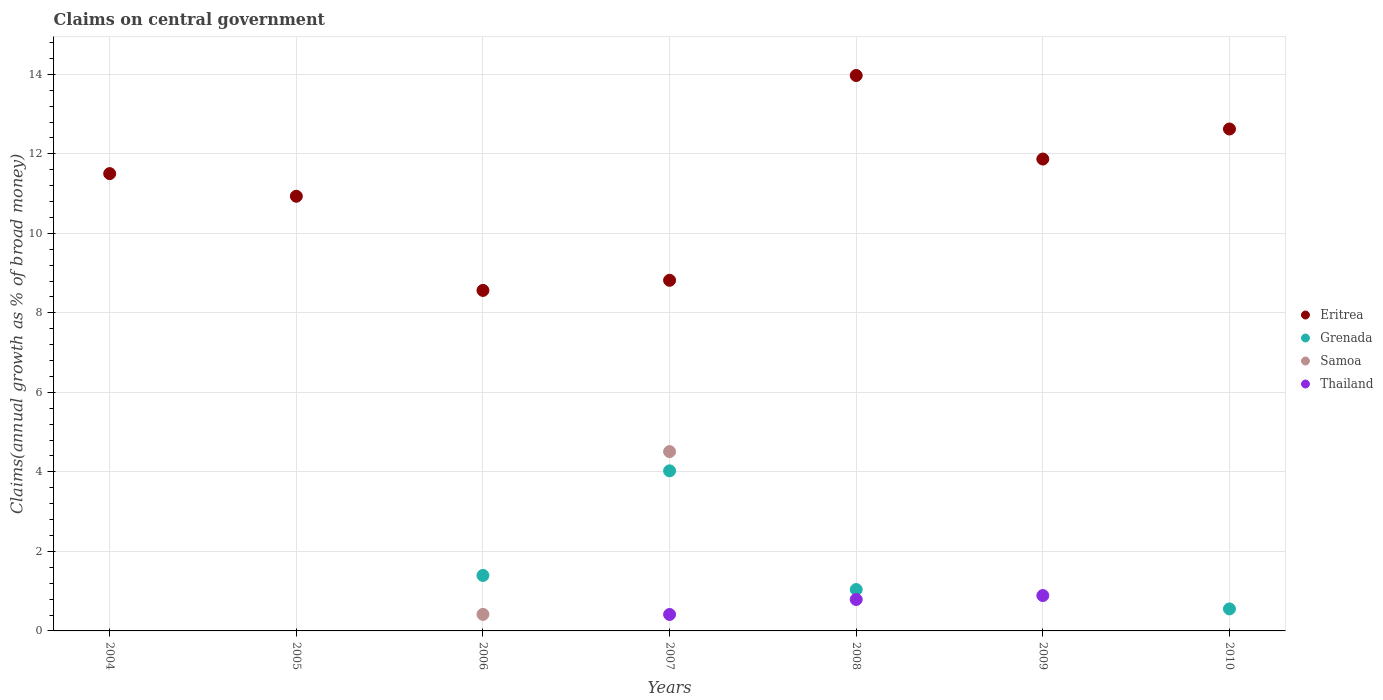How many different coloured dotlines are there?
Keep it short and to the point. 4. What is the percentage of broad money claimed on centeral government in Samoa in 2009?
Your answer should be compact. 0. Across all years, what is the maximum percentage of broad money claimed on centeral government in Thailand?
Offer a very short reply. 0.89. Across all years, what is the minimum percentage of broad money claimed on centeral government in Samoa?
Provide a succinct answer. 0. What is the total percentage of broad money claimed on centeral government in Eritrea in the graph?
Your answer should be very brief. 78.28. What is the difference between the percentage of broad money claimed on centeral government in Thailand in 2007 and that in 2009?
Offer a very short reply. -0.48. What is the difference between the percentage of broad money claimed on centeral government in Eritrea in 2006 and the percentage of broad money claimed on centeral government in Samoa in 2005?
Offer a very short reply. 8.56. What is the average percentage of broad money claimed on centeral government in Thailand per year?
Provide a succinct answer. 0.3. In the year 2007, what is the difference between the percentage of broad money claimed on centeral government in Grenada and percentage of broad money claimed on centeral government in Thailand?
Ensure brevity in your answer.  3.61. In how many years, is the percentage of broad money claimed on centeral government in Eritrea greater than 9.2 %?
Keep it short and to the point. 5. What is the ratio of the percentage of broad money claimed on centeral government in Grenada in 2008 to that in 2010?
Your response must be concise. 1.88. What is the difference between the highest and the second highest percentage of broad money claimed on centeral government in Grenada?
Keep it short and to the point. 2.63. What is the difference between the highest and the lowest percentage of broad money claimed on centeral government in Samoa?
Your response must be concise. 4.51. Is it the case that in every year, the sum of the percentage of broad money claimed on centeral government in Samoa and percentage of broad money claimed on centeral government in Eritrea  is greater than the sum of percentage of broad money claimed on centeral government in Thailand and percentage of broad money claimed on centeral government in Grenada?
Ensure brevity in your answer.  Yes. Is the percentage of broad money claimed on centeral government in Eritrea strictly greater than the percentage of broad money claimed on centeral government in Grenada over the years?
Your answer should be compact. Yes. Is the percentage of broad money claimed on centeral government in Eritrea strictly less than the percentage of broad money claimed on centeral government in Samoa over the years?
Keep it short and to the point. No. What is the difference between two consecutive major ticks on the Y-axis?
Keep it short and to the point. 2. Are the values on the major ticks of Y-axis written in scientific E-notation?
Provide a short and direct response. No. Does the graph contain any zero values?
Keep it short and to the point. Yes. Where does the legend appear in the graph?
Offer a very short reply. Center right. What is the title of the graph?
Give a very brief answer. Claims on central government. Does "Fiji" appear as one of the legend labels in the graph?
Ensure brevity in your answer.  No. What is the label or title of the X-axis?
Your answer should be compact. Years. What is the label or title of the Y-axis?
Keep it short and to the point. Claims(annual growth as % of broad money). What is the Claims(annual growth as % of broad money) in Eritrea in 2004?
Give a very brief answer. 11.5. What is the Claims(annual growth as % of broad money) in Thailand in 2004?
Offer a terse response. 0. What is the Claims(annual growth as % of broad money) in Eritrea in 2005?
Your answer should be very brief. 10.93. What is the Claims(annual growth as % of broad money) of Eritrea in 2006?
Your answer should be compact. 8.56. What is the Claims(annual growth as % of broad money) of Grenada in 2006?
Provide a short and direct response. 1.4. What is the Claims(annual growth as % of broad money) in Samoa in 2006?
Offer a very short reply. 0.42. What is the Claims(annual growth as % of broad money) in Thailand in 2006?
Ensure brevity in your answer.  0. What is the Claims(annual growth as % of broad money) in Eritrea in 2007?
Your response must be concise. 8.82. What is the Claims(annual growth as % of broad money) in Grenada in 2007?
Give a very brief answer. 4.03. What is the Claims(annual growth as % of broad money) in Samoa in 2007?
Ensure brevity in your answer.  4.51. What is the Claims(annual growth as % of broad money) in Thailand in 2007?
Give a very brief answer. 0.41. What is the Claims(annual growth as % of broad money) of Eritrea in 2008?
Your answer should be very brief. 13.97. What is the Claims(annual growth as % of broad money) in Grenada in 2008?
Your answer should be very brief. 1.04. What is the Claims(annual growth as % of broad money) in Samoa in 2008?
Provide a succinct answer. 0. What is the Claims(annual growth as % of broad money) of Thailand in 2008?
Provide a succinct answer. 0.79. What is the Claims(annual growth as % of broad money) in Eritrea in 2009?
Ensure brevity in your answer.  11.87. What is the Claims(annual growth as % of broad money) of Samoa in 2009?
Make the answer very short. 0. What is the Claims(annual growth as % of broad money) of Thailand in 2009?
Provide a succinct answer. 0.89. What is the Claims(annual growth as % of broad money) of Eritrea in 2010?
Your response must be concise. 12.62. What is the Claims(annual growth as % of broad money) in Grenada in 2010?
Ensure brevity in your answer.  0.55. What is the Claims(annual growth as % of broad money) in Samoa in 2010?
Ensure brevity in your answer.  0. Across all years, what is the maximum Claims(annual growth as % of broad money) of Eritrea?
Offer a very short reply. 13.97. Across all years, what is the maximum Claims(annual growth as % of broad money) of Grenada?
Your response must be concise. 4.03. Across all years, what is the maximum Claims(annual growth as % of broad money) of Samoa?
Make the answer very short. 4.51. Across all years, what is the maximum Claims(annual growth as % of broad money) in Thailand?
Ensure brevity in your answer.  0.89. Across all years, what is the minimum Claims(annual growth as % of broad money) in Eritrea?
Your answer should be very brief. 8.56. Across all years, what is the minimum Claims(annual growth as % of broad money) in Grenada?
Offer a very short reply. 0. Across all years, what is the minimum Claims(annual growth as % of broad money) in Samoa?
Provide a short and direct response. 0. What is the total Claims(annual growth as % of broad money) in Eritrea in the graph?
Provide a succinct answer. 78.28. What is the total Claims(annual growth as % of broad money) in Grenada in the graph?
Give a very brief answer. 7.02. What is the total Claims(annual growth as % of broad money) in Samoa in the graph?
Your response must be concise. 4.93. What is the total Claims(annual growth as % of broad money) of Thailand in the graph?
Your answer should be very brief. 2.09. What is the difference between the Claims(annual growth as % of broad money) in Eritrea in 2004 and that in 2005?
Provide a short and direct response. 0.57. What is the difference between the Claims(annual growth as % of broad money) of Eritrea in 2004 and that in 2006?
Provide a short and direct response. 2.94. What is the difference between the Claims(annual growth as % of broad money) in Eritrea in 2004 and that in 2007?
Make the answer very short. 2.68. What is the difference between the Claims(annual growth as % of broad money) in Eritrea in 2004 and that in 2008?
Provide a succinct answer. -2.47. What is the difference between the Claims(annual growth as % of broad money) in Eritrea in 2004 and that in 2009?
Provide a short and direct response. -0.37. What is the difference between the Claims(annual growth as % of broad money) of Eritrea in 2004 and that in 2010?
Your answer should be compact. -1.12. What is the difference between the Claims(annual growth as % of broad money) of Eritrea in 2005 and that in 2006?
Offer a terse response. 2.37. What is the difference between the Claims(annual growth as % of broad money) of Eritrea in 2005 and that in 2007?
Ensure brevity in your answer.  2.11. What is the difference between the Claims(annual growth as % of broad money) in Eritrea in 2005 and that in 2008?
Offer a very short reply. -3.04. What is the difference between the Claims(annual growth as % of broad money) in Eritrea in 2005 and that in 2009?
Ensure brevity in your answer.  -0.94. What is the difference between the Claims(annual growth as % of broad money) in Eritrea in 2005 and that in 2010?
Provide a short and direct response. -1.69. What is the difference between the Claims(annual growth as % of broad money) of Eritrea in 2006 and that in 2007?
Provide a succinct answer. -0.25. What is the difference between the Claims(annual growth as % of broad money) of Grenada in 2006 and that in 2007?
Keep it short and to the point. -2.63. What is the difference between the Claims(annual growth as % of broad money) of Samoa in 2006 and that in 2007?
Ensure brevity in your answer.  -4.09. What is the difference between the Claims(annual growth as % of broad money) in Eritrea in 2006 and that in 2008?
Make the answer very short. -5.41. What is the difference between the Claims(annual growth as % of broad money) of Grenada in 2006 and that in 2008?
Keep it short and to the point. 0.35. What is the difference between the Claims(annual growth as % of broad money) in Eritrea in 2006 and that in 2009?
Keep it short and to the point. -3.3. What is the difference between the Claims(annual growth as % of broad money) in Eritrea in 2006 and that in 2010?
Give a very brief answer. -4.06. What is the difference between the Claims(annual growth as % of broad money) in Grenada in 2006 and that in 2010?
Provide a short and direct response. 0.84. What is the difference between the Claims(annual growth as % of broad money) of Eritrea in 2007 and that in 2008?
Ensure brevity in your answer.  -5.15. What is the difference between the Claims(annual growth as % of broad money) of Grenada in 2007 and that in 2008?
Your answer should be compact. 2.98. What is the difference between the Claims(annual growth as % of broad money) of Thailand in 2007 and that in 2008?
Ensure brevity in your answer.  -0.38. What is the difference between the Claims(annual growth as % of broad money) in Eritrea in 2007 and that in 2009?
Your answer should be compact. -3.05. What is the difference between the Claims(annual growth as % of broad money) of Thailand in 2007 and that in 2009?
Offer a terse response. -0.48. What is the difference between the Claims(annual growth as % of broad money) in Eritrea in 2007 and that in 2010?
Give a very brief answer. -3.81. What is the difference between the Claims(annual growth as % of broad money) in Grenada in 2007 and that in 2010?
Make the answer very short. 3.47. What is the difference between the Claims(annual growth as % of broad money) of Eritrea in 2008 and that in 2009?
Offer a terse response. 2.1. What is the difference between the Claims(annual growth as % of broad money) in Thailand in 2008 and that in 2009?
Provide a succinct answer. -0.1. What is the difference between the Claims(annual growth as % of broad money) of Eritrea in 2008 and that in 2010?
Provide a succinct answer. 1.35. What is the difference between the Claims(annual growth as % of broad money) in Grenada in 2008 and that in 2010?
Give a very brief answer. 0.49. What is the difference between the Claims(annual growth as % of broad money) of Eritrea in 2009 and that in 2010?
Offer a very short reply. -0.76. What is the difference between the Claims(annual growth as % of broad money) of Eritrea in 2004 and the Claims(annual growth as % of broad money) of Grenada in 2006?
Offer a very short reply. 10.11. What is the difference between the Claims(annual growth as % of broad money) in Eritrea in 2004 and the Claims(annual growth as % of broad money) in Samoa in 2006?
Provide a succinct answer. 11.09. What is the difference between the Claims(annual growth as % of broad money) of Eritrea in 2004 and the Claims(annual growth as % of broad money) of Grenada in 2007?
Keep it short and to the point. 7.48. What is the difference between the Claims(annual growth as % of broad money) of Eritrea in 2004 and the Claims(annual growth as % of broad money) of Samoa in 2007?
Keep it short and to the point. 6.99. What is the difference between the Claims(annual growth as % of broad money) of Eritrea in 2004 and the Claims(annual growth as % of broad money) of Thailand in 2007?
Your response must be concise. 11.09. What is the difference between the Claims(annual growth as % of broad money) in Eritrea in 2004 and the Claims(annual growth as % of broad money) in Grenada in 2008?
Give a very brief answer. 10.46. What is the difference between the Claims(annual growth as % of broad money) of Eritrea in 2004 and the Claims(annual growth as % of broad money) of Thailand in 2008?
Offer a terse response. 10.71. What is the difference between the Claims(annual growth as % of broad money) in Eritrea in 2004 and the Claims(annual growth as % of broad money) in Thailand in 2009?
Make the answer very short. 10.61. What is the difference between the Claims(annual growth as % of broad money) in Eritrea in 2004 and the Claims(annual growth as % of broad money) in Grenada in 2010?
Ensure brevity in your answer.  10.95. What is the difference between the Claims(annual growth as % of broad money) of Eritrea in 2005 and the Claims(annual growth as % of broad money) of Grenada in 2006?
Your answer should be very brief. 9.54. What is the difference between the Claims(annual growth as % of broad money) of Eritrea in 2005 and the Claims(annual growth as % of broad money) of Samoa in 2006?
Offer a very short reply. 10.52. What is the difference between the Claims(annual growth as % of broad money) in Eritrea in 2005 and the Claims(annual growth as % of broad money) in Grenada in 2007?
Keep it short and to the point. 6.91. What is the difference between the Claims(annual growth as % of broad money) of Eritrea in 2005 and the Claims(annual growth as % of broad money) of Samoa in 2007?
Provide a succinct answer. 6.42. What is the difference between the Claims(annual growth as % of broad money) in Eritrea in 2005 and the Claims(annual growth as % of broad money) in Thailand in 2007?
Ensure brevity in your answer.  10.52. What is the difference between the Claims(annual growth as % of broad money) of Eritrea in 2005 and the Claims(annual growth as % of broad money) of Grenada in 2008?
Your answer should be compact. 9.89. What is the difference between the Claims(annual growth as % of broad money) of Eritrea in 2005 and the Claims(annual growth as % of broad money) of Thailand in 2008?
Your answer should be compact. 10.14. What is the difference between the Claims(annual growth as % of broad money) in Eritrea in 2005 and the Claims(annual growth as % of broad money) in Thailand in 2009?
Give a very brief answer. 10.04. What is the difference between the Claims(annual growth as % of broad money) of Eritrea in 2005 and the Claims(annual growth as % of broad money) of Grenada in 2010?
Your answer should be very brief. 10.38. What is the difference between the Claims(annual growth as % of broad money) of Eritrea in 2006 and the Claims(annual growth as % of broad money) of Grenada in 2007?
Keep it short and to the point. 4.54. What is the difference between the Claims(annual growth as % of broad money) in Eritrea in 2006 and the Claims(annual growth as % of broad money) in Samoa in 2007?
Ensure brevity in your answer.  4.05. What is the difference between the Claims(annual growth as % of broad money) in Eritrea in 2006 and the Claims(annual growth as % of broad money) in Thailand in 2007?
Ensure brevity in your answer.  8.15. What is the difference between the Claims(annual growth as % of broad money) in Grenada in 2006 and the Claims(annual growth as % of broad money) in Samoa in 2007?
Your answer should be very brief. -3.12. What is the difference between the Claims(annual growth as % of broad money) in Grenada in 2006 and the Claims(annual growth as % of broad money) in Thailand in 2007?
Offer a very short reply. 0.98. What is the difference between the Claims(annual growth as % of broad money) of Samoa in 2006 and the Claims(annual growth as % of broad money) of Thailand in 2007?
Your answer should be compact. 0. What is the difference between the Claims(annual growth as % of broad money) in Eritrea in 2006 and the Claims(annual growth as % of broad money) in Grenada in 2008?
Ensure brevity in your answer.  7.52. What is the difference between the Claims(annual growth as % of broad money) of Eritrea in 2006 and the Claims(annual growth as % of broad money) of Thailand in 2008?
Your response must be concise. 7.77. What is the difference between the Claims(annual growth as % of broad money) in Grenada in 2006 and the Claims(annual growth as % of broad money) in Thailand in 2008?
Give a very brief answer. 0.6. What is the difference between the Claims(annual growth as % of broad money) of Samoa in 2006 and the Claims(annual growth as % of broad money) of Thailand in 2008?
Offer a very short reply. -0.37. What is the difference between the Claims(annual growth as % of broad money) of Eritrea in 2006 and the Claims(annual growth as % of broad money) of Thailand in 2009?
Your answer should be compact. 7.68. What is the difference between the Claims(annual growth as % of broad money) of Grenada in 2006 and the Claims(annual growth as % of broad money) of Thailand in 2009?
Your answer should be compact. 0.51. What is the difference between the Claims(annual growth as % of broad money) in Samoa in 2006 and the Claims(annual growth as % of broad money) in Thailand in 2009?
Your answer should be very brief. -0.47. What is the difference between the Claims(annual growth as % of broad money) of Eritrea in 2006 and the Claims(annual growth as % of broad money) of Grenada in 2010?
Your answer should be compact. 8.01. What is the difference between the Claims(annual growth as % of broad money) of Eritrea in 2007 and the Claims(annual growth as % of broad money) of Grenada in 2008?
Ensure brevity in your answer.  7.78. What is the difference between the Claims(annual growth as % of broad money) of Eritrea in 2007 and the Claims(annual growth as % of broad money) of Thailand in 2008?
Ensure brevity in your answer.  8.03. What is the difference between the Claims(annual growth as % of broad money) in Grenada in 2007 and the Claims(annual growth as % of broad money) in Thailand in 2008?
Give a very brief answer. 3.24. What is the difference between the Claims(annual growth as % of broad money) in Samoa in 2007 and the Claims(annual growth as % of broad money) in Thailand in 2008?
Offer a terse response. 3.72. What is the difference between the Claims(annual growth as % of broad money) of Eritrea in 2007 and the Claims(annual growth as % of broad money) of Thailand in 2009?
Give a very brief answer. 7.93. What is the difference between the Claims(annual growth as % of broad money) in Grenada in 2007 and the Claims(annual growth as % of broad money) in Thailand in 2009?
Keep it short and to the point. 3.14. What is the difference between the Claims(annual growth as % of broad money) in Samoa in 2007 and the Claims(annual growth as % of broad money) in Thailand in 2009?
Ensure brevity in your answer.  3.62. What is the difference between the Claims(annual growth as % of broad money) in Eritrea in 2007 and the Claims(annual growth as % of broad money) in Grenada in 2010?
Give a very brief answer. 8.26. What is the difference between the Claims(annual growth as % of broad money) of Eritrea in 2008 and the Claims(annual growth as % of broad money) of Thailand in 2009?
Offer a terse response. 13.08. What is the difference between the Claims(annual growth as % of broad money) in Grenada in 2008 and the Claims(annual growth as % of broad money) in Thailand in 2009?
Offer a very short reply. 0.15. What is the difference between the Claims(annual growth as % of broad money) of Eritrea in 2008 and the Claims(annual growth as % of broad money) of Grenada in 2010?
Ensure brevity in your answer.  13.42. What is the difference between the Claims(annual growth as % of broad money) in Eritrea in 2009 and the Claims(annual growth as % of broad money) in Grenada in 2010?
Make the answer very short. 11.31. What is the average Claims(annual growth as % of broad money) in Eritrea per year?
Provide a succinct answer. 11.18. What is the average Claims(annual growth as % of broad money) of Samoa per year?
Ensure brevity in your answer.  0.7. What is the average Claims(annual growth as % of broad money) of Thailand per year?
Offer a terse response. 0.3. In the year 2006, what is the difference between the Claims(annual growth as % of broad money) of Eritrea and Claims(annual growth as % of broad money) of Grenada?
Provide a succinct answer. 7.17. In the year 2006, what is the difference between the Claims(annual growth as % of broad money) of Eritrea and Claims(annual growth as % of broad money) of Samoa?
Give a very brief answer. 8.15. In the year 2006, what is the difference between the Claims(annual growth as % of broad money) of Grenada and Claims(annual growth as % of broad money) of Samoa?
Make the answer very short. 0.98. In the year 2007, what is the difference between the Claims(annual growth as % of broad money) of Eritrea and Claims(annual growth as % of broad money) of Grenada?
Keep it short and to the point. 4.79. In the year 2007, what is the difference between the Claims(annual growth as % of broad money) in Eritrea and Claims(annual growth as % of broad money) in Samoa?
Provide a succinct answer. 4.31. In the year 2007, what is the difference between the Claims(annual growth as % of broad money) in Eritrea and Claims(annual growth as % of broad money) in Thailand?
Your answer should be very brief. 8.4. In the year 2007, what is the difference between the Claims(annual growth as % of broad money) of Grenada and Claims(annual growth as % of broad money) of Samoa?
Keep it short and to the point. -0.48. In the year 2007, what is the difference between the Claims(annual growth as % of broad money) of Grenada and Claims(annual growth as % of broad money) of Thailand?
Give a very brief answer. 3.61. In the year 2007, what is the difference between the Claims(annual growth as % of broad money) in Samoa and Claims(annual growth as % of broad money) in Thailand?
Give a very brief answer. 4.1. In the year 2008, what is the difference between the Claims(annual growth as % of broad money) in Eritrea and Claims(annual growth as % of broad money) in Grenada?
Your answer should be compact. 12.93. In the year 2008, what is the difference between the Claims(annual growth as % of broad money) in Eritrea and Claims(annual growth as % of broad money) in Thailand?
Keep it short and to the point. 13.18. In the year 2008, what is the difference between the Claims(annual growth as % of broad money) of Grenada and Claims(annual growth as % of broad money) of Thailand?
Your response must be concise. 0.25. In the year 2009, what is the difference between the Claims(annual growth as % of broad money) in Eritrea and Claims(annual growth as % of broad money) in Thailand?
Give a very brief answer. 10.98. In the year 2010, what is the difference between the Claims(annual growth as % of broad money) of Eritrea and Claims(annual growth as % of broad money) of Grenada?
Your response must be concise. 12.07. What is the ratio of the Claims(annual growth as % of broad money) in Eritrea in 2004 to that in 2005?
Your answer should be very brief. 1.05. What is the ratio of the Claims(annual growth as % of broad money) in Eritrea in 2004 to that in 2006?
Offer a very short reply. 1.34. What is the ratio of the Claims(annual growth as % of broad money) in Eritrea in 2004 to that in 2007?
Offer a very short reply. 1.3. What is the ratio of the Claims(annual growth as % of broad money) in Eritrea in 2004 to that in 2008?
Provide a succinct answer. 0.82. What is the ratio of the Claims(annual growth as % of broad money) in Eritrea in 2004 to that in 2009?
Ensure brevity in your answer.  0.97. What is the ratio of the Claims(annual growth as % of broad money) in Eritrea in 2004 to that in 2010?
Make the answer very short. 0.91. What is the ratio of the Claims(annual growth as % of broad money) of Eritrea in 2005 to that in 2006?
Keep it short and to the point. 1.28. What is the ratio of the Claims(annual growth as % of broad money) in Eritrea in 2005 to that in 2007?
Offer a terse response. 1.24. What is the ratio of the Claims(annual growth as % of broad money) of Eritrea in 2005 to that in 2008?
Provide a succinct answer. 0.78. What is the ratio of the Claims(annual growth as % of broad money) of Eritrea in 2005 to that in 2009?
Give a very brief answer. 0.92. What is the ratio of the Claims(annual growth as % of broad money) of Eritrea in 2005 to that in 2010?
Your answer should be very brief. 0.87. What is the ratio of the Claims(annual growth as % of broad money) in Eritrea in 2006 to that in 2007?
Provide a short and direct response. 0.97. What is the ratio of the Claims(annual growth as % of broad money) in Grenada in 2006 to that in 2007?
Ensure brevity in your answer.  0.35. What is the ratio of the Claims(annual growth as % of broad money) of Samoa in 2006 to that in 2007?
Ensure brevity in your answer.  0.09. What is the ratio of the Claims(annual growth as % of broad money) of Eritrea in 2006 to that in 2008?
Your answer should be very brief. 0.61. What is the ratio of the Claims(annual growth as % of broad money) of Grenada in 2006 to that in 2008?
Provide a short and direct response. 1.34. What is the ratio of the Claims(annual growth as % of broad money) of Eritrea in 2006 to that in 2009?
Your answer should be compact. 0.72. What is the ratio of the Claims(annual growth as % of broad money) of Eritrea in 2006 to that in 2010?
Give a very brief answer. 0.68. What is the ratio of the Claims(annual growth as % of broad money) of Grenada in 2006 to that in 2010?
Offer a terse response. 2.52. What is the ratio of the Claims(annual growth as % of broad money) of Eritrea in 2007 to that in 2008?
Offer a terse response. 0.63. What is the ratio of the Claims(annual growth as % of broad money) of Grenada in 2007 to that in 2008?
Make the answer very short. 3.87. What is the ratio of the Claims(annual growth as % of broad money) in Thailand in 2007 to that in 2008?
Your response must be concise. 0.52. What is the ratio of the Claims(annual growth as % of broad money) in Eritrea in 2007 to that in 2009?
Provide a succinct answer. 0.74. What is the ratio of the Claims(annual growth as % of broad money) in Thailand in 2007 to that in 2009?
Your answer should be compact. 0.47. What is the ratio of the Claims(annual growth as % of broad money) in Eritrea in 2007 to that in 2010?
Make the answer very short. 0.7. What is the ratio of the Claims(annual growth as % of broad money) of Grenada in 2007 to that in 2010?
Your response must be concise. 7.27. What is the ratio of the Claims(annual growth as % of broad money) in Eritrea in 2008 to that in 2009?
Offer a very short reply. 1.18. What is the ratio of the Claims(annual growth as % of broad money) in Thailand in 2008 to that in 2009?
Provide a short and direct response. 0.89. What is the ratio of the Claims(annual growth as % of broad money) in Eritrea in 2008 to that in 2010?
Your answer should be very brief. 1.11. What is the ratio of the Claims(annual growth as % of broad money) in Grenada in 2008 to that in 2010?
Keep it short and to the point. 1.88. What is the ratio of the Claims(annual growth as % of broad money) in Eritrea in 2009 to that in 2010?
Your answer should be compact. 0.94. What is the difference between the highest and the second highest Claims(annual growth as % of broad money) in Eritrea?
Ensure brevity in your answer.  1.35. What is the difference between the highest and the second highest Claims(annual growth as % of broad money) in Grenada?
Make the answer very short. 2.63. What is the difference between the highest and the second highest Claims(annual growth as % of broad money) of Thailand?
Your answer should be compact. 0.1. What is the difference between the highest and the lowest Claims(annual growth as % of broad money) in Eritrea?
Offer a terse response. 5.41. What is the difference between the highest and the lowest Claims(annual growth as % of broad money) in Grenada?
Give a very brief answer. 4.03. What is the difference between the highest and the lowest Claims(annual growth as % of broad money) in Samoa?
Keep it short and to the point. 4.51. What is the difference between the highest and the lowest Claims(annual growth as % of broad money) of Thailand?
Give a very brief answer. 0.89. 